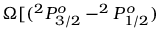<formula> <loc_0><loc_0><loc_500><loc_500>\Omega [ ( ^ { 2 } P _ { 3 / 2 } ^ { o } - ^ { 2 } P _ { 1 / 2 } ^ { o } )</formula> 